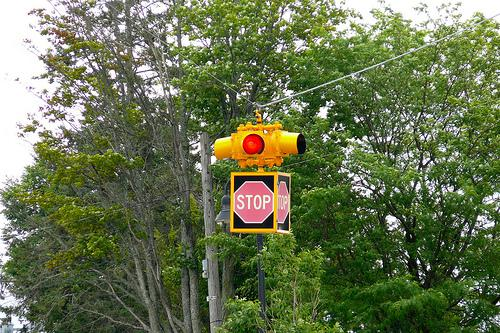Question: what is above the stop sign?
Choices:
A. Street sign.
B. Direction arrow.
C. A traffic light.
D. Grafetti.
Answer with the letter. Answer: C Question: when was the photo taken?
Choices:
A. During the day.
B. Dawn.
C. Late afternoon.
D. Night.
Answer with the letter. Answer: A Question: who is in the picture?
Choices:
A. A man.
B. Chidren.
C. Two dogs.
D. Nobody.
Answer with the letter. Answer: D Question: where is the traffic light?
Choices:
A. Above the street.
B. On a pole.
C. On a wire.
D. Attached to overpass.
Answer with the letter. Answer: A Question: why is it there?
Choices:
A. Sweep street.
B. Repair traffic light.
C. Responding to accident.
D. To stop traffic.
Answer with the letter. Answer: D Question: how many stop signs are there?
Choices:
A. One.
B. Three.
C. Four.
D. Two.
Answer with the letter. Answer: D Question: what is behind the stop sign?
Choices:
A. A building.
B. Billboard.
C. Cars.
D. Trees.
Answer with the letter. Answer: D 